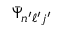Convert formula to latex. <formula><loc_0><loc_0><loc_500><loc_500>\bar { \Psi } _ { n ^ { \prime } \ell ^ { \prime } j ^ { \prime } }</formula> 